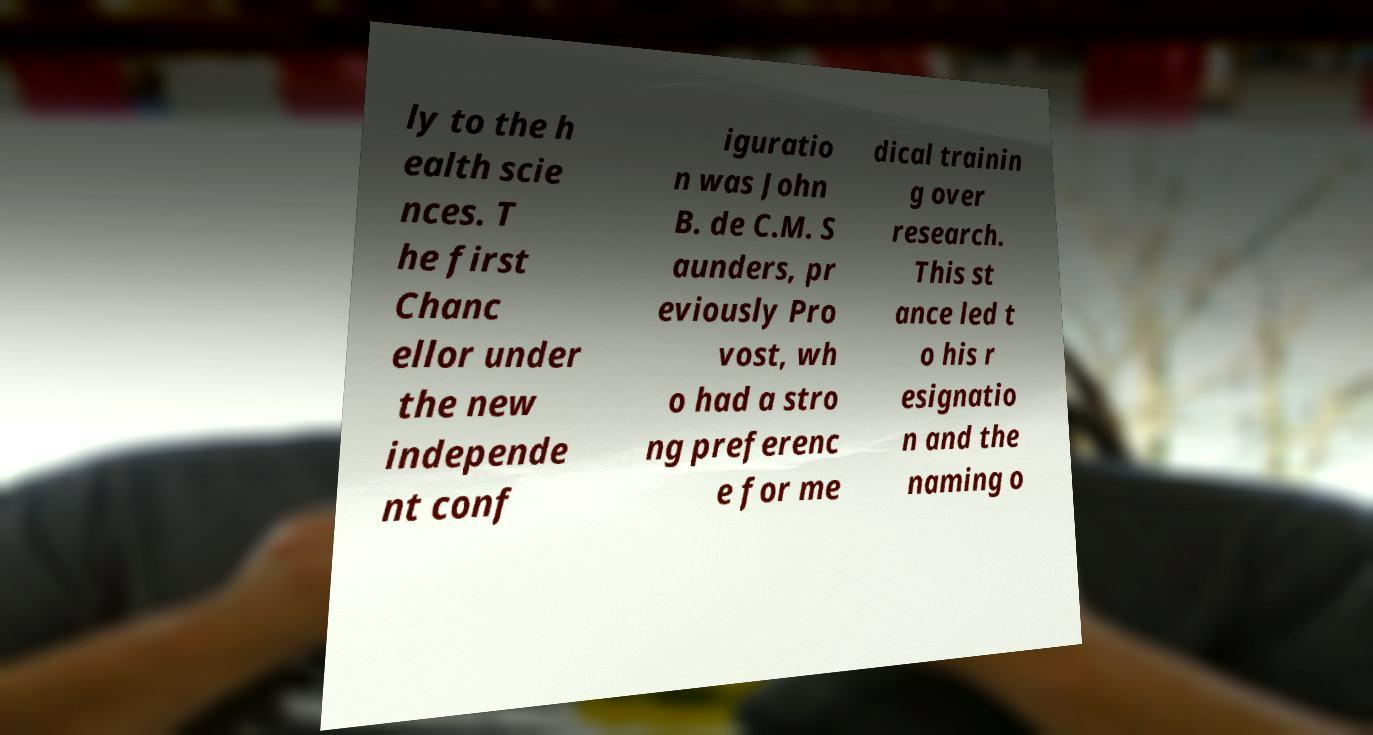Could you assist in decoding the text presented in this image and type it out clearly? ly to the h ealth scie nces. T he first Chanc ellor under the new independe nt conf iguratio n was John B. de C.M. S aunders, pr eviously Pro vost, wh o had a stro ng preferenc e for me dical trainin g over research. This st ance led t o his r esignatio n and the naming o 